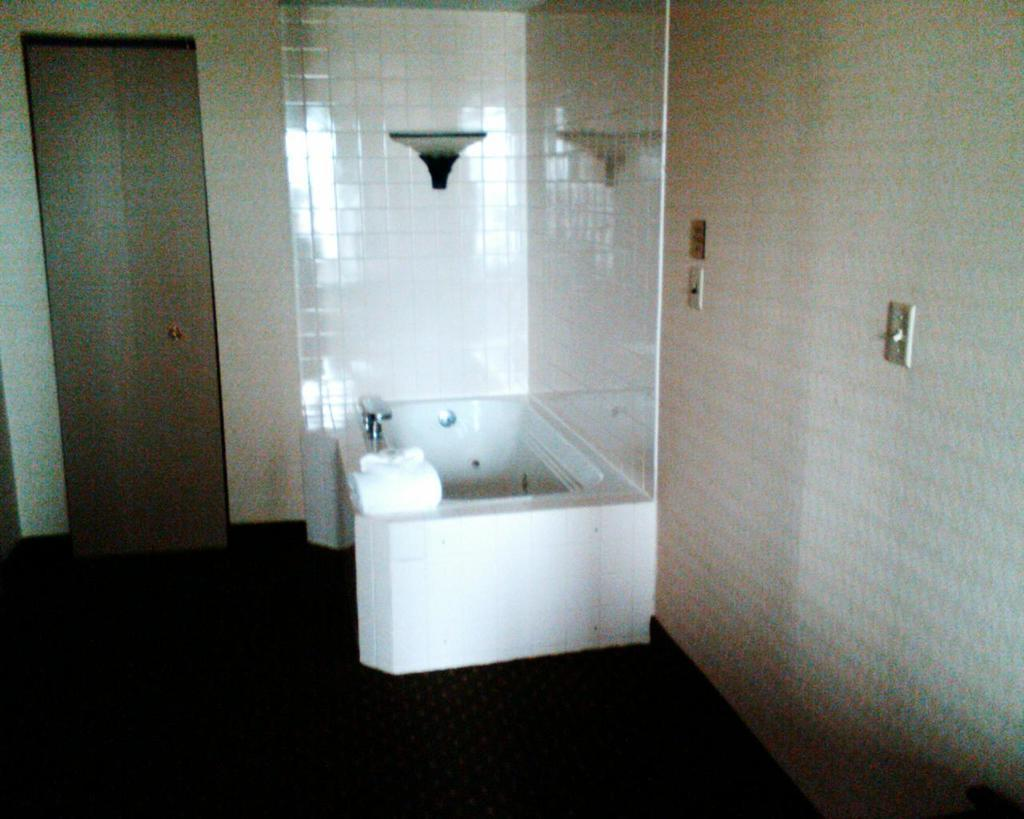What type of room is depicted in the image? The image appears to depict a restroom. What is one of the main fixtures in the restroom? There is a bathtub in the image. Where is the door located in the image? The door is on the left side of the image. What can be found on the wall in the image? There are switches on the wall in the image. How does the ship navigate the twist in the image? There is no ship present in the image; it depicts a restroom with a bathtub, door, and switches. 